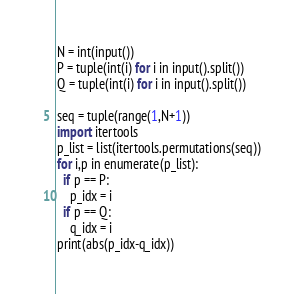<code> <loc_0><loc_0><loc_500><loc_500><_Python_>N = int(input())
P = tuple(int(i) for i in input().split())
Q = tuple(int(i) for i in input().split())

seq = tuple(range(1,N+1))
import itertools
p_list = list(itertools.permutations(seq))
for i,p in enumerate(p_list):
  if p == P:
    p_idx = i
  if p == Q:
    q_idx = i
print(abs(p_idx-q_idx))
</code> 